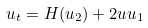<formula> <loc_0><loc_0><loc_500><loc_500>u _ { t } = H ( u _ { 2 } ) + 2 u u _ { 1 }</formula> 